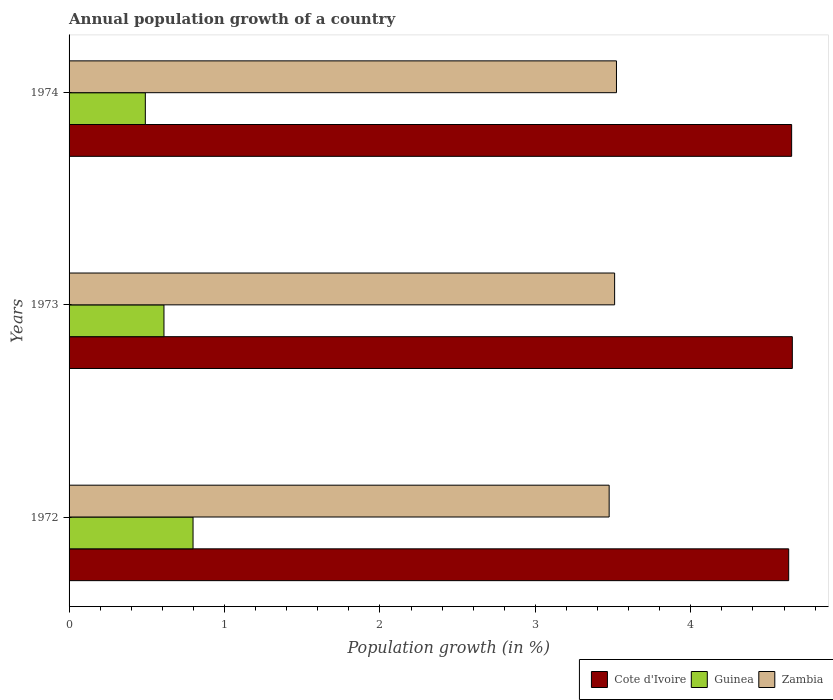How many bars are there on the 2nd tick from the top?
Offer a terse response. 3. In how many cases, is the number of bars for a given year not equal to the number of legend labels?
Make the answer very short. 0. What is the annual population growth in Cote d'Ivoire in 1974?
Ensure brevity in your answer.  4.65. Across all years, what is the maximum annual population growth in Cote d'Ivoire?
Ensure brevity in your answer.  4.65. Across all years, what is the minimum annual population growth in Cote d'Ivoire?
Your answer should be very brief. 4.63. In which year was the annual population growth in Cote d'Ivoire minimum?
Offer a very short reply. 1972. What is the total annual population growth in Cote d'Ivoire in the graph?
Ensure brevity in your answer.  13.93. What is the difference between the annual population growth in Cote d'Ivoire in 1972 and that in 1973?
Offer a very short reply. -0.02. What is the difference between the annual population growth in Guinea in 1972 and the annual population growth in Cote d'Ivoire in 1974?
Offer a very short reply. -3.85. What is the average annual population growth in Guinea per year?
Keep it short and to the point. 0.63. In the year 1973, what is the difference between the annual population growth in Guinea and annual population growth in Zambia?
Keep it short and to the point. -2.9. What is the ratio of the annual population growth in Guinea in 1972 to that in 1973?
Provide a short and direct response. 1.31. Is the annual population growth in Cote d'Ivoire in 1972 less than that in 1974?
Provide a succinct answer. Yes. What is the difference between the highest and the second highest annual population growth in Cote d'Ivoire?
Your answer should be compact. 0. What is the difference between the highest and the lowest annual population growth in Cote d'Ivoire?
Your response must be concise. 0.02. In how many years, is the annual population growth in Cote d'Ivoire greater than the average annual population growth in Cote d'Ivoire taken over all years?
Give a very brief answer. 2. What does the 3rd bar from the top in 1973 represents?
Provide a succinct answer. Cote d'Ivoire. What does the 2nd bar from the bottom in 1973 represents?
Offer a terse response. Guinea. Is it the case that in every year, the sum of the annual population growth in Cote d'Ivoire and annual population growth in Zambia is greater than the annual population growth in Guinea?
Your response must be concise. Yes. Are the values on the major ticks of X-axis written in scientific E-notation?
Offer a terse response. No. Does the graph contain grids?
Make the answer very short. No. What is the title of the graph?
Give a very brief answer. Annual population growth of a country. Does "Heavily indebted poor countries" appear as one of the legend labels in the graph?
Give a very brief answer. No. What is the label or title of the X-axis?
Provide a short and direct response. Population growth (in %). What is the label or title of the Y-axis?
Your answer should be compact. Years. What is the Population growth (in %) in Cote d'Ivoire in 1972?
Your response must be concise. 4.63. What is the Population growth (in %) of Guinea in 1972?
Your answer should be very brief. 0.8. What is the Population growth (in %) of Zambia in 1972?
Provide a succinct answer. 3.47. What is the Population growth (in %) of Cote d'Ivoire in 1973?
Your response must be concise. 4.65. What is the Population growth (in %) in Guinea in 1973?
Give a very brief answer. 0.61. What is the Population growth (in %) in Zambia in 1973?
Make the answer very short. 3.51. What is the Population growth (in %) of Cote d'Ivoire in 1974?
Offer a terse response. 4.65. What is the Population growth (in %) of Guinea in 1974?
Your answer should be very brief. 0.49. What is the Population growth (in %) of Zambia in 1974?
Offer a terse response. 3.52. Across all years, what is the maximum Population growth (in %) in Cote d'Ivoire?
Make the answer very short. 4.65. Across all years, what is the maximum Population growth (in %) in Guinea?
Your answer should be compact. 0.8. Across all years, what is the maximum Population growth (in %) of Zambia?
Provide a succinct answer. 3.52. Across all years, what is the minimum Population growth (in %) in Cote d'Ivoire?
Keep it short and to the point. 4.63. Across all years, what is the minimum Population growth (in %) of Guinea?
Provide a succinct answer. 0.49. Across all years, what is the minimum Population growth (in %) of Zambia?
Offer a very short reply. 3.47. What is the total Population growth (in %) of Cote d'Ivoire in the graph?
Your answer should be very brief. 13.93. What is the total Population growth (in %) in Guinea in the graph?
Provide a succinct answer. 1.9. What is the total Population growth (in %) of Zambia in the graph?
Make the answer very short. 10.51. What is the difference between the Population growth (in %) of Cote d'Ivoire in 1972 and that in 1973?
Your response must be concise. -0.02. What is the difference between the Population growth (in %) of Guinea in 1972 and that in 1973?
Keep it short and to the point. 0.19. What is the difference between the Population growth (in %) in Zambia in 1972 and that in 1973?
Offer a terse response. -0.04. What is the difference between the Population growth (in %) of Cote d'Ivoire in 1972 and that in 1974?
Offer a very short reply. -0.02. What is the difference between the Population growth (in %) of Guinea in 1972 and that in 1974?
Offer a very short reply. 0.31. What is the difference between the Population growth (in %) in Zambia in 1972 and that in 1974?
Your response must be concise. -0.05. What is the difference between the Population growth (in %) in Cote d'Ivoire in 1973 and that in 1974?
Offer a very short reply. 0. What is the difference between the Population growth (in %) of Guinea in 1973 and that in 1974?
Offer a very short reply. 0.12. What is the difference between the Population growth (in %) in Zambia in 1973 and that in 1974?
Your response must be concise. -0.01. What is the difference between the Population growth (in %) in Cote d'Ivoire in 1972 and the Population growth (in %) in Guinea in 1973?
Your answer should be compact. 4.02. What is the difference between the Population growth (in %) of Cote d'Ivoire in 1972 and the Population growth (in %) of Zambia in 1973?
Offer a terse response. 1.12. What is the difference between the Population growth (in %) of Guinea in 1972 and the Population growth (in %) of Zambia in 1973?
Provide a short and direct response. -2.71. What is the difference between the Population growth (in %) of Cote d'Ivoire in 1972 and the Population growth (in %) of Guinea in 1974?
Provide a short and direct response. 4.14. What is the difference between the Population growth (in %) in Cote d'Ivoire in 1972 and the Population growth (in %) in Zambia in 1974?
Your answer should be very brief. 1.11. What is the difference between the Population growth (in %) in Guinea in 1972 and the Population growth (in %) in Zambia in 1974?
Your response must be concise. -2.72. What is the difference between the Population growth (in %) of Cote d'Ivoire in 1973 and the Population growth (in %) of Guinea in 1974?
Your response must be concise. 4.16. What is the difference between the Population growth (in %) of Cote d'Ivoire in 1973 and the Population growth (in %) of Zambia in 1974?
Keep it short and to the point. 1.13. What is the difference between the Population growth (in %) in Guinea in 1973 and the Population growth (in %) in Zambia in 1974?
Keep it short and to the point. -2.91. What is the average Population growth (in %) in Cote d'Ivoire per year?
Offer a terse response. 4.64. What is the average Population growth (in %) in Guinea per year?
Provide a succinct answer. 0.63. What is the average Population growth (in %) of Zambia per year?
Your response must be concise. 3.5. In the year 1972, what is the difference between the Population growth (in %) in Cote d'Ivoire and Population growth (in %) in Guinea?
Ensure brevity in your answer.  3.83. In the year 1972, what is the difference between the Population growth (in %) in Cote d'Ivoire and Population growth (in %) in Zambia?
Make the answer very short. 1.16. In the year 1972, what is the difference between the Population growth (in %) of Guinea and Population growth (in %) of Zambia?
Your response must be concise. -2.68. In the year 1973, what is the difference between the Population growth (in %) in Cote d'Ivoire and Population growth (in %) in Guinea?
Your response must be concise. 4.04. In the year 1973, what is the difference between the Population growth (in %) of Cote d'Ivoire and Population growth (in %) of Zambia?
Keep it short and to the point. 1.14. In the year 1973, what is the difference between the Population growth (in %) of Guinea and Population growth (in %) of Zambia?
Provide a short and direct response. -2.9. In the year 1974, what is the difference between the Population growth (in %) of Cote d'Ivoire and Population growth (in %) of Guinea?
Give a very brief answer. 4.16. In the year 1974, what is the difference between the Population growth (in %) in Cote d'Ivoire and Population growth (in %) in Zambia?
Ensure brevity in your answer.  1.13. In the year 1974, what is the difference between the Population growth (in %) in Guinea and Population growth (in %) in Zambia?
Offer a very short reply. -3.03. What is the ratio of the Population growth (in %) in Cote d'Ivoire in 1972 to that in 1973?
Ensure brevity in your answer.  0.99. What is the ratio of the Population growth (in %) in Guinea in 1972 to that in 1973?
Ensure brevity in your answer.  1.31. What is the ratio of the Population growth (in %) of Zambia in 1972 to that in 1973?
Provide a short and direct response. 0.99. What is the ratio of the Population growth (in %) in Cote d'Ivoire in 1972 to that in 1974?
Offer a terse response. 1. What is the ratio of the Population growth (in %) in Guinea in 1972 to that in 1974?
Provide a short and direct response. 1.63. What is the ratio of the Population growth (in %) in Zambia in 1972 to that in 1974?
Provide a short and direct response. 0.99. What is the ratio of the Population growth (in %) of Cote d'Ivoire in 1973 to that in 1974?
Your answer should be very brief. 1. What is the ratio of the Population growth (in %) of Guinea in 1973 to that in 1974?
Your answer should be very brief. 1.24. What is the difference between the highest and the second highest Population growth (in %) of Cote d'Ivoire?
Offer a terse response. 0. What is the difference between the highest and the second highest Population growth (in %) in Guinea?
Make the answer very short. 0.19. What is the difference between the highest and the second highest Population growth (in %) in Zambia?
Your response must be concise. 0.01. What is the difference between the highest and the lowest Population growth (in %) in Cote d'Ivoire?
Provide a short and direct response. 0.02. What is the difference between the highest and the lowest Population growth (in %) of Guinea?
Keep it short and to the point. 0.31. What is the difference between the highest and the lowest Population growth (in %) in Zambia?
Offer a terse response. 0.05. 